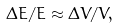<formula> <loc_0><loc_0><loc_500><loc_500>\Delta E / E \approx \Delta V / V ,</formula> 